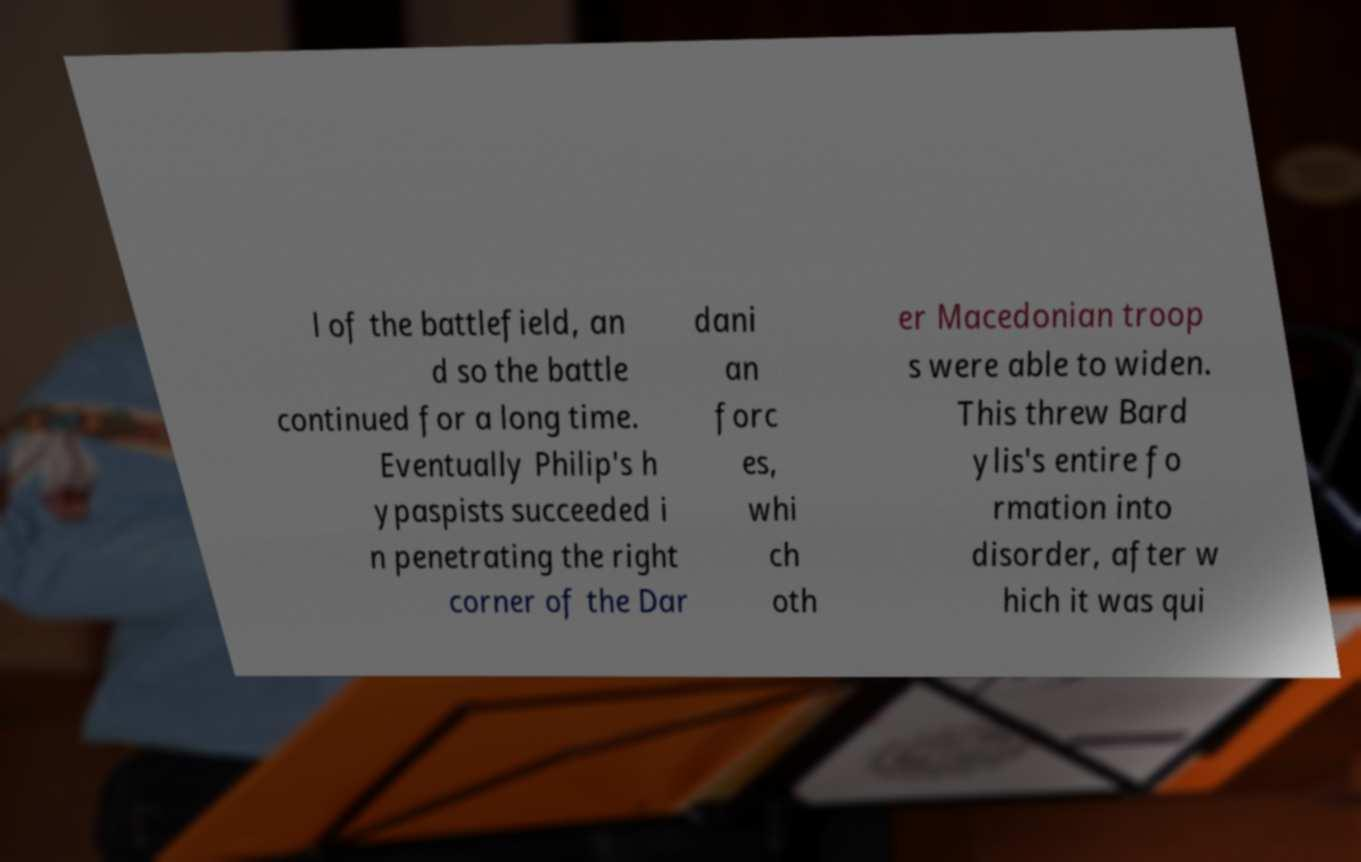There's text embedded in this image that I need extracted. Can you transcribe it verbatim? l of the battlefield, an d so the battle continued for a long time. Eventually Philip's h ypaspists succeeded i n penetrating the right corner of the Dar dani an forc es, whi ch oth er Macedonian troop s were able to widen. This threw Bard ylis's entire fo rmation into disorder, after w hich it was qui 